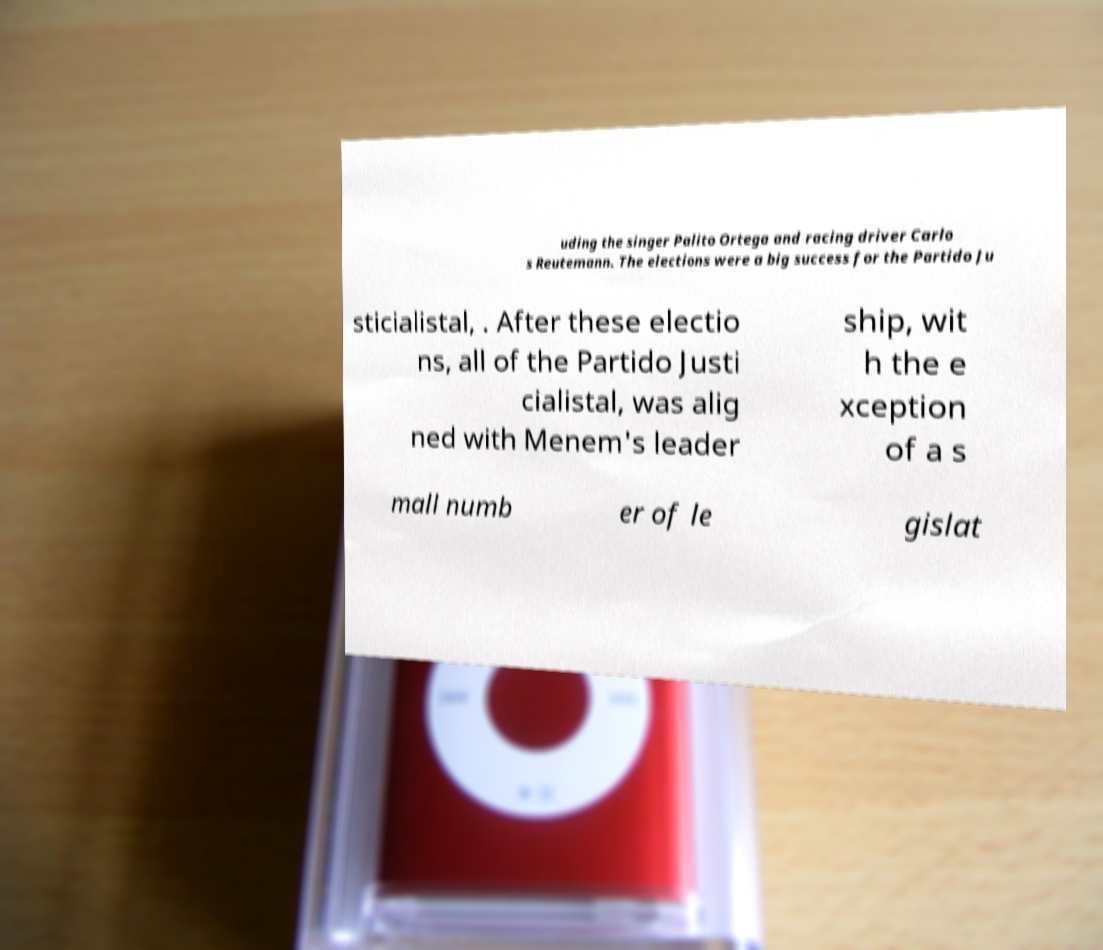For documentation purposes, I need the text within this image transcribed. Could you provide that? uding the singer Palito Ortega and racing driver Carlo s Reutemann. The elections were a big success for the Partido Ju sticialistal, . After these electio ns, all of the Partido Justi cialistal, was alig ned with Menem's leader ship, wit h the e xception of a s mall numb er of le gislat 